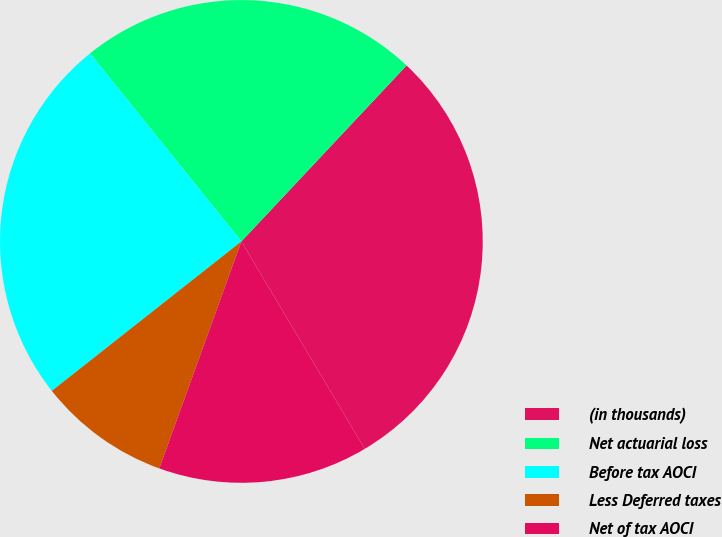Convert chart. <chart><loc_0><loc_0><loc_500><loc_500><pie_chart><fcel>(in thousands)<fcel>Net actuarial loss<fcel>Before tax AOCI<fcel>Less Deferred taxes<fcel>Net of tax AOCI<nl><fcel>29.46%<fcel>22.78%<fcel>24.84%<fcel>8.85%<fcel>14.06%<nl></chart> 